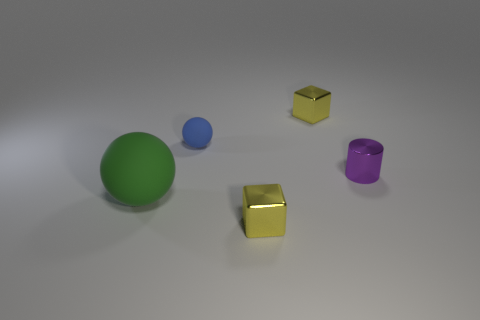Subtract 2 spheres. How many spheres are left? 0 Add 2 cyan metal spheres. How many objects exist? 7 Subtract all blue balls. How many balls are left? 1 Subtract 0 red spheres. How many objects are left? 5 Subtract all balls. How many objects are left? 3 Subtract all brown spheres. Subtract all blue cylinders. How many spheres are left? 2 Subtract all red cubes. How many blue spheres are left? 1 Subtract all metal cubes. Subtract all small metallic objects. How many objects are left? 0 Add 5 cubes. How many cubes are left? 7 Add 1 purple shiny things. How many purple shiny things exist? 2 